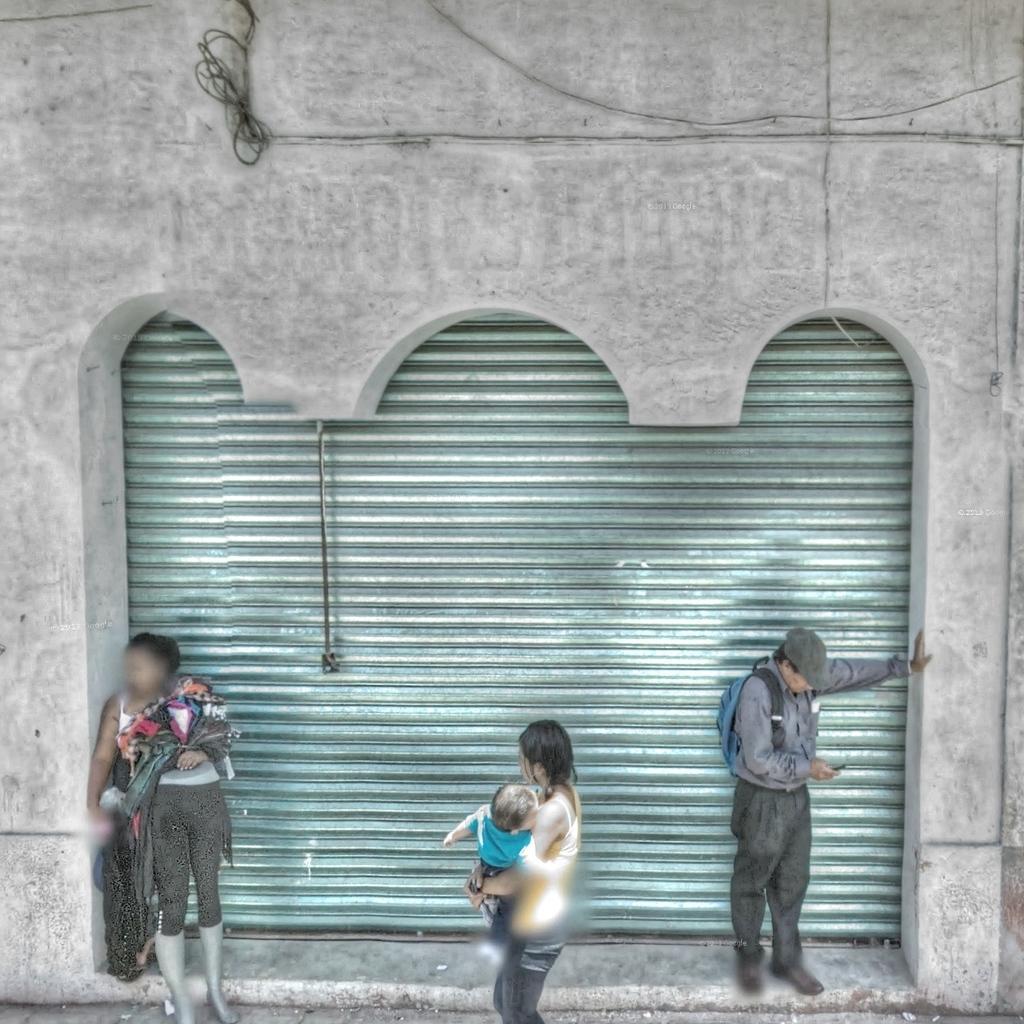In one or two sentences, can you explain what this image depicts? In the foreground of this image, there are three persons. Behind them, there is a shutter. On the top, there are cables and the wall. 